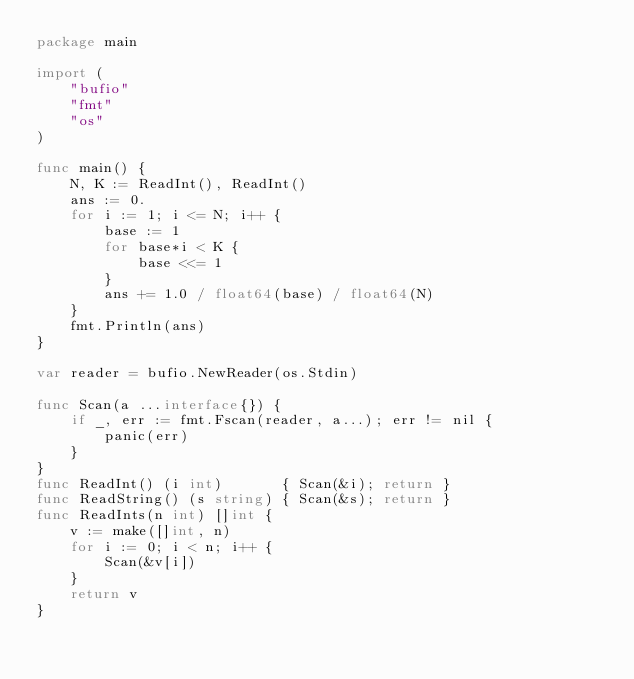Convert code to text. <code><loc_0><loc_0><loc_500><loc_500><_Go_>package main

import (
	"bufio"
	"fmt"
	"os"
)

func main() {
	N, K := ReadInt(), ReadInt()
	ans := 0.
	for i := 1; i <= N; i++ {
		base := 1
		for base*i < K {
			base <<= 1
		}
		ans += 1.0 / float64(base) / float64(N)
	}
	fmt.Println(ans)
}

var reader = bufio.NewReader(os.Stdin)

func Scan(a ...interface{}) {
	if _, err := fmt.Fscan(reader, a...); err != nil {
		panic(err)
	}
}
func ReadInt() (i int)       { Scan(&i); return }
func ReadString() (s string) { Scan(&s); return }
func ReadInts(n int) []int {
	v := make([]int, n)
	for i := 0; i < n; i++ {
		Scan(&v[i])
	}
	return v
}
</code> 